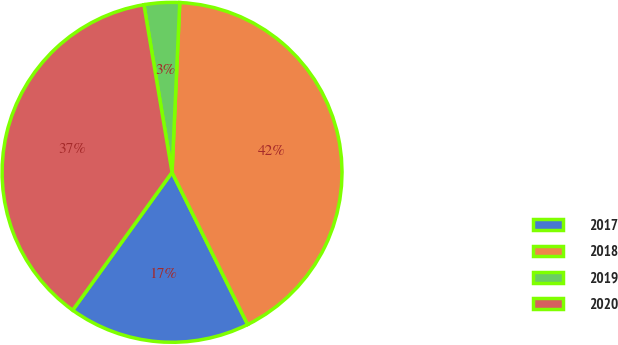Convert chart to OTSL. <chart><loc_0><loc_0><loc_500><loc_500><pie_chart><fcel>2017<fcel>2018<fcel>2019<fcel>2020<nl><fcel>17.28%<fcel>41.94%<fcel>3.37%<fcel>37.42%<nl></chart> 